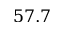Convert formula to latex. <formula><loc_0><loc_0><loc_500><loc_500>5 7 . 7</formula> 